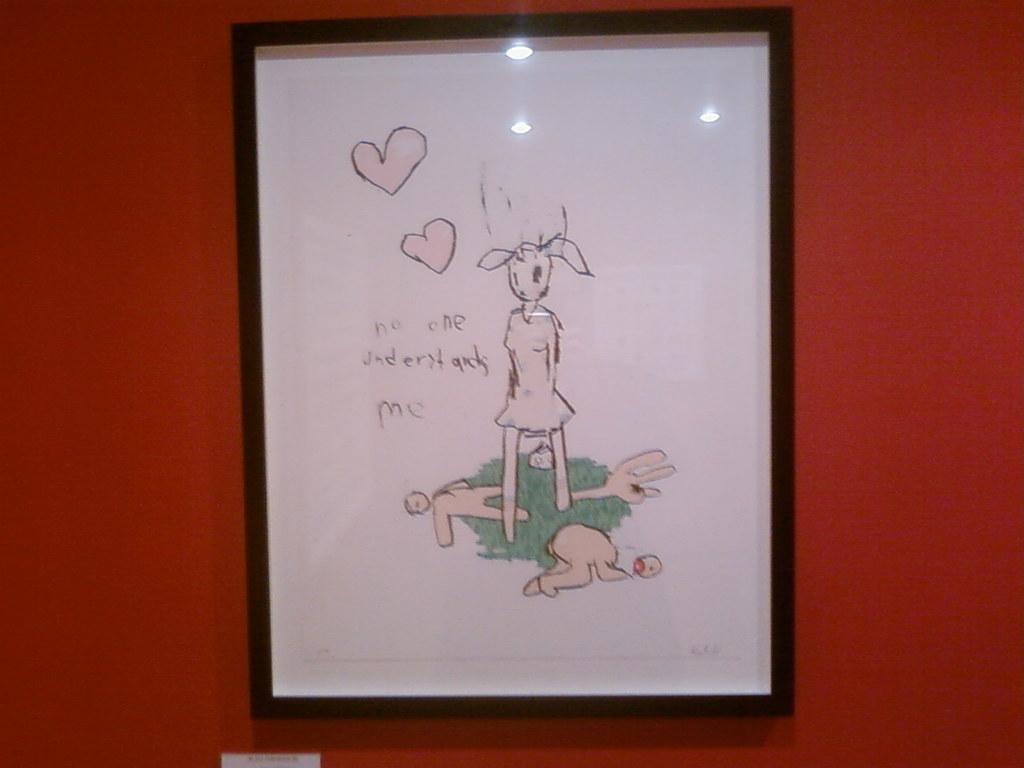<image>
Write a terse but informative summary of the picture. Portrait that says "Noone understands Me" with a rabbit holding a balloon. 